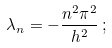<formula> <loc_0><loc_0><loc_500><loc_500>\lambda _ { n } = - \frac { n ^ { 2 } \pi ^ { 2 } } { h ^ { 2 } } \, ;</formula> 